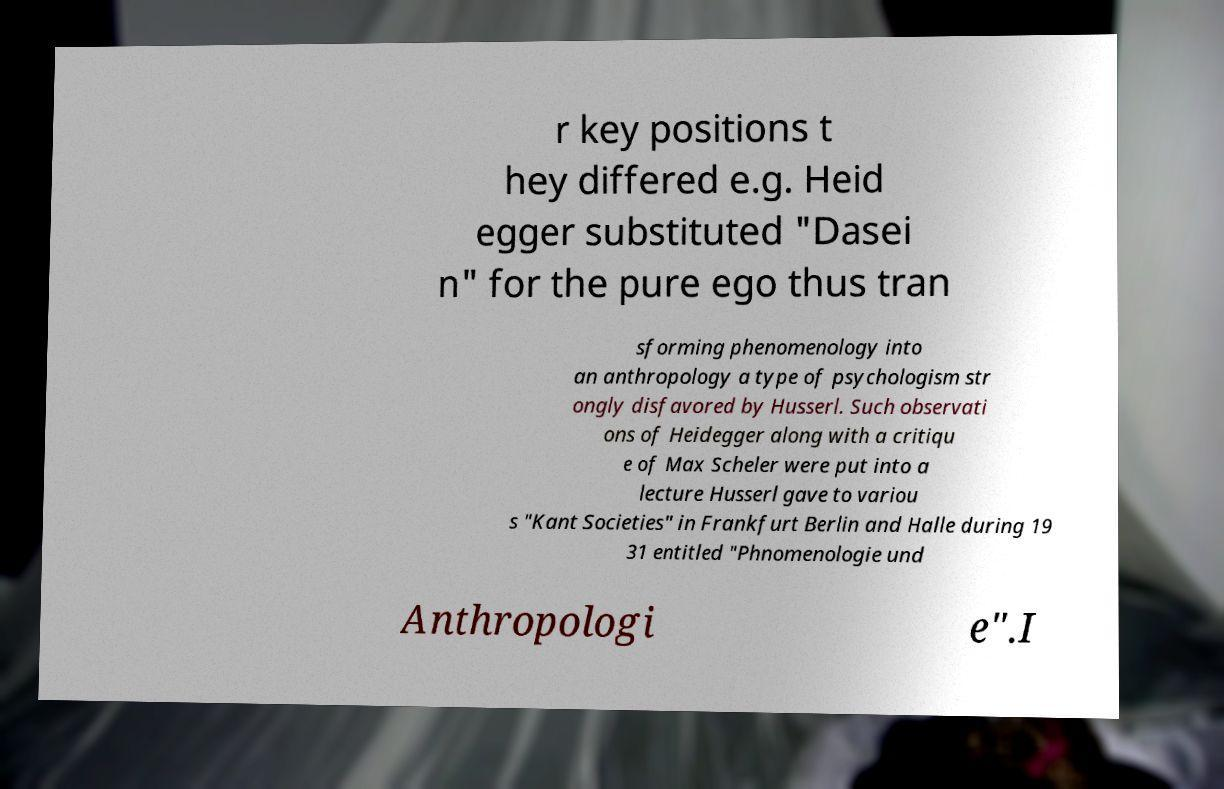Could you extract and type out the text from this image? r key positions t hey differed e.g. Heid egger substituted "Dasei n" for the pure ego thus tran sforming phenomenology into an anthropology a type of psychologism str ongly disfavored by Husserl. Such observati ons of Heidegger along with a critiqu e of Max Scheler were put into a lecture Husserl gave to variou s "Kant Societies" in Frankfurt Berlin and Halle during 19 31 entitled "Phnomenologie und Anthropologi e".I 